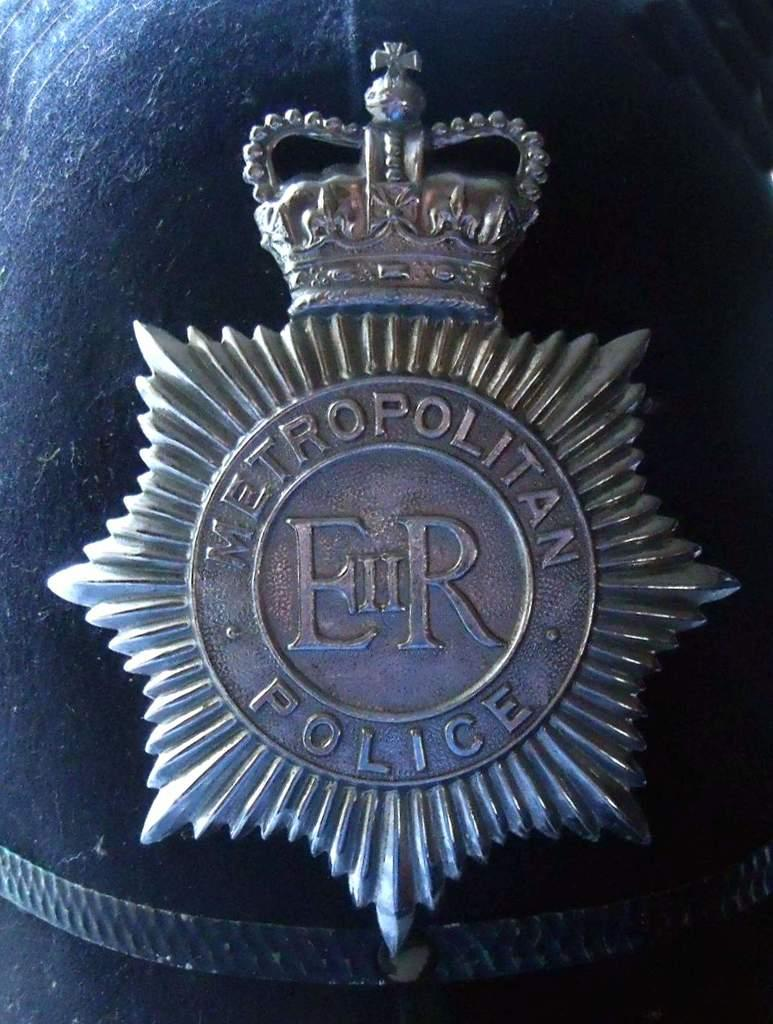<image>
Provide a brief description of the given image. the letters ER that are on some kind of metal piece 